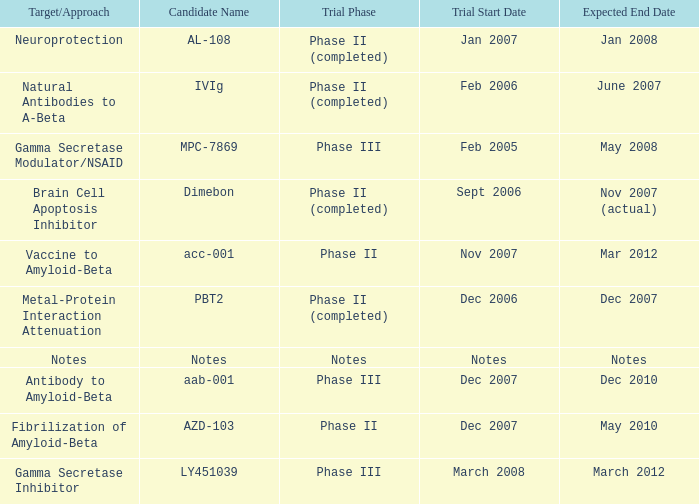What is Candidate Name, when Target/Approach is "vaccine to amyloid-beta"? Acc-001. 